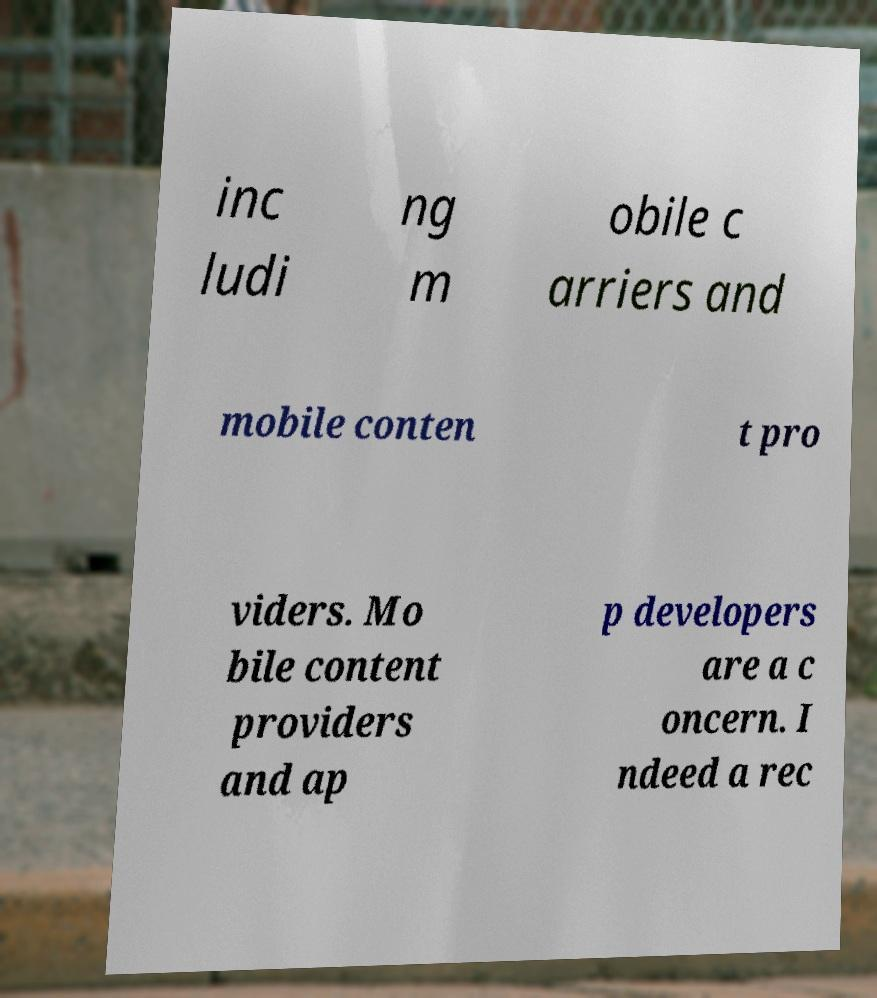There's text embedded in this image that I need extracted. Can you transcribe it verbatim? inc ludi ng m obile c arriers and mobile conten t pro viders. Mo bile content providers and ap p developers are a c oncern. I ndeed a rec 